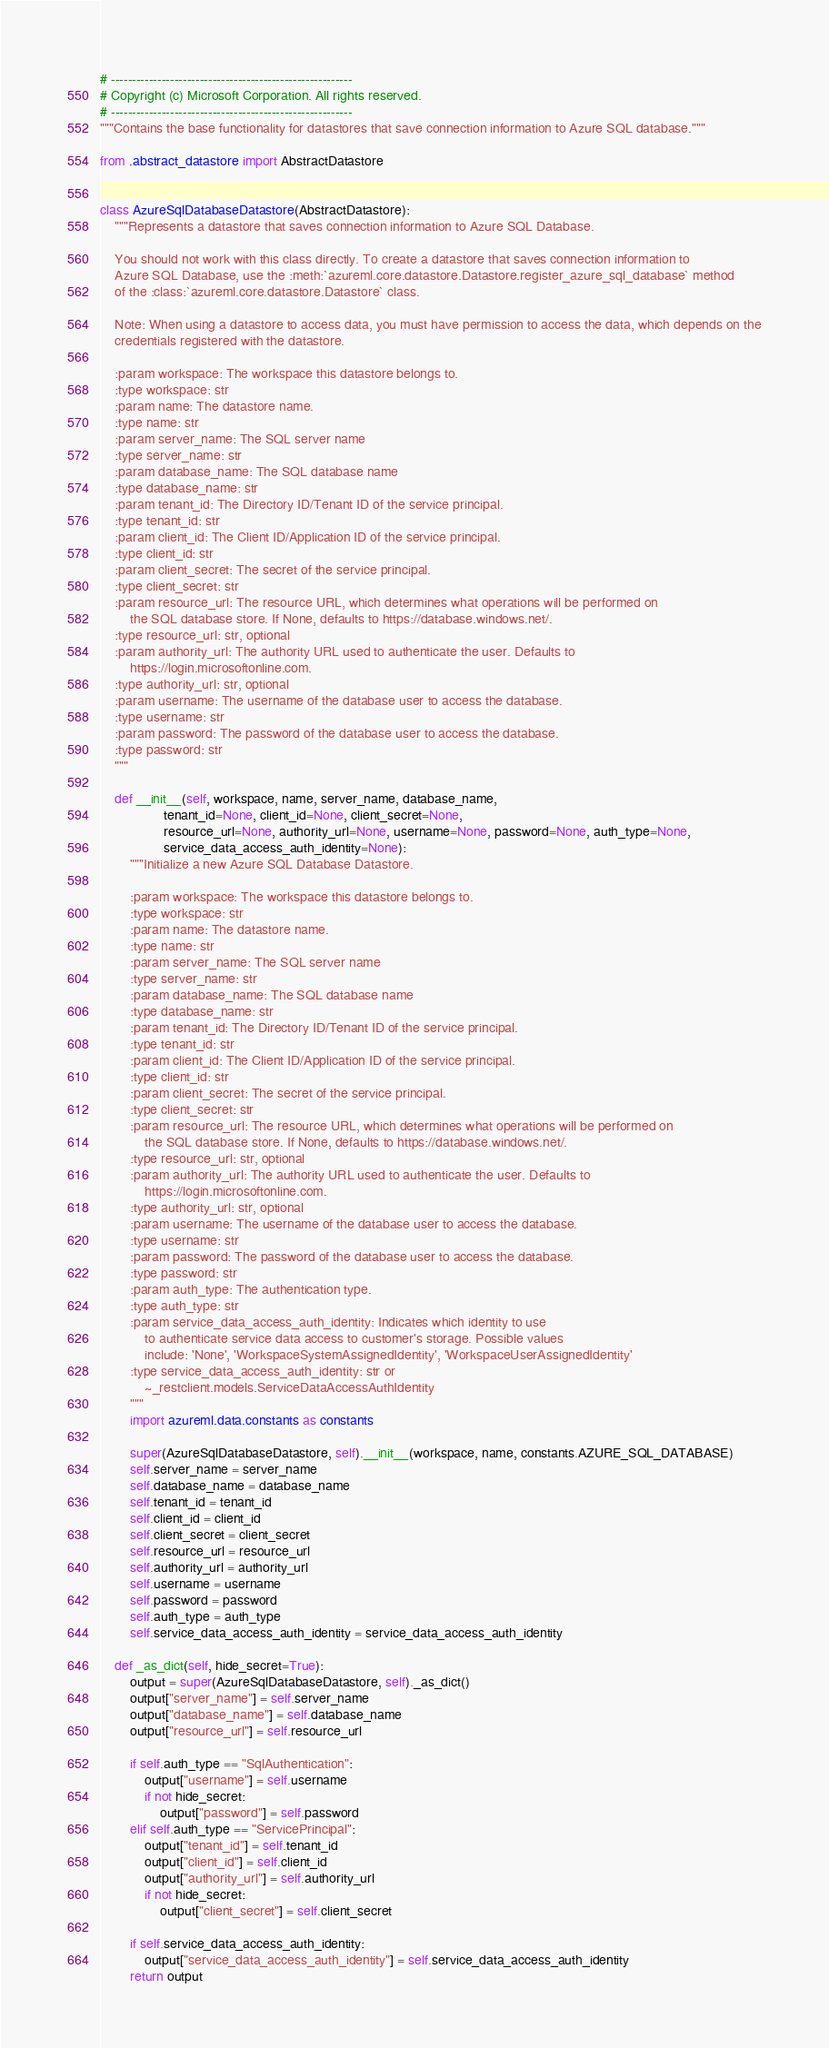<code> <loc_0><loc_0><loc_500><loc_500><_Python_># ---------------------------------------------------------
# Copyright (c) Microsoft Corporation. All rights reserved.
# ---------------------------------------------------------
"""Contains the base functionality for datastores that save connection information to Azure SQL database."""

from .abstract_datastore import AbstractDatastore


class AzureSqlDatabaseDatastore(AbstractDatastore):
    """Represents a datastore that saves connection information to Azure SQL Database.

    You should not work with this class directly. To create a datastore that saves connection information to
    Azure SQL Database, use the :meth:`azureml.core.datastore.Datastore.register_azure_sql_database` method
    of the :class:`azureml.core.datastore.Datastore` class.

    Note: When using a datastore to access data, you must have permission to access the data, which depends on the
    credentials registered with the datastore.

    :param workspace: The workspace this datastore belongs to.
    :type workspace: str
    :param name: The datastore name.
    :type name: str
    :param server_name: The SQL server name
    :type server_name: str
    :param database_name: The SQL database name
    :type database_name: str
    :param tenant_id: The Directory ID/Tenant ID of the service principal.
    :type tenant_id: str
    :param client_id: The Client ID/Application ID of the service principal.
    :type client_id: str
    :param client_secret: The secret of the service principal.
    :type client_secret: str
    :param resource_url: The resource URL, which determines what operations will be performed on
        the SQL database store. If None, defaults to https://database.windows.net/.
    :type resource_url: str, optional
    :param authority_url: The authority URL used to authenticate the user. Defaults to
        https://login.microsoftonline.com.
    :type authority_url: str, optional
    :param username: The username of the database user to access the database.
    :type username: str
    :param password: The password of the database user to access the database.
    :type password: str
    """

    def __init__(self, workspace, name, server_name, database_name,
                 tenant_id=None, client_id=None, client_secret=None,
                 resource_url=None, authority_url=None, username=None, password=None, auth_type=None,
                 service_data_access_auth_identity=None):
        """Initialize a new Azure SQL Database Datastore.

        :param workspace: The workspace this datastore belongs to.
        :type workspace: str
        :param name: The datastore name.
        :type name: str
        :param server_name: The SQL server name
        :type server_name: str
        :param database_name: The SQL database name
        :type database_name: str
        :param tenant_id: The Directory ID/Tenant ID of the service principal.
        :type tenant_id: str
        :param client_id: The Client ID/Application ID of the service principal.
        :type client_id: str
        :param client_secret: The secret of the service principal.
        :type client_secret: str
        :param resource_url: The resource URL, which determines what operations will be performed on
            the SQL database store. If None, defaults to https://database.windows.net/.
        :type resource_url: str, optional
        :param authority_url: The authority URL used to authenticate the user. Defaults to
            https://login.microsoftonline.com.
        :type authority_url: str, optional
        :param username: The username of the database user to access the database.
        :type username: str
        :param password: The password of the database user to access the database.
        :type password: str
        :param auth_type: The authentication type.
        :type auth_type: str
        :param service_data_access_auth_identity: Indicates which identity to use
            to authenticate service data access to customer's storage. Possible values
            include: 'None', 'WorkspaceSystemAssignedIdentity', 'WorkspaceUserAssignedIdentity'
        :type service_data_access_auth_identity: str or
            ~_restclient.models.ServiceDataAccessAuthIdentity
        """
        import azureml.data.constants as constants

        super(AzureSqlDatabaseDatastore, self).__init__(workspace, name, constants.AZURE_SQL_DATABASE)
        self.server_name = server_name
        self.database_name = database_name
        self.tenant_id = tenant_id
        self.client_id = client_id
        self.client_secret = client_secret
        self.resource_url = resource_url
        self.authority_url = authority_url
        self.username = username
        self.password = password
        self.auth_type = auth_type
        self.service_data_access_auth_identity = service_data_access_auth_identity

    def _as_dict(self, hide_secret=True):
        output = super(AzureSqlDatabaseDatastore, self)._as_dict()
        output["server_name"] = self.server_name
        output["database_name"] = self.database_name
        output["resource_url"] = self.resource_url

        if self.auth_type == "SqlAuthentication":
            output["username"] = self.username
            if not hide_secret:
                output["password"] = self.password
        elif self.auth_type == "ServicePrincipal":
            output["tenant_id"] = self.tenant_id
            output["client_id"] = self.client_id
            output["authority_url"] = self.authority_url
            if not hide_secret:
                output["client_secret"] = self.client_secret

        if self.service_data_access_auth_identity:
            output["service_data_access_auth_identity"] = self.service_data_access_auth_identity
        return output
</code> 